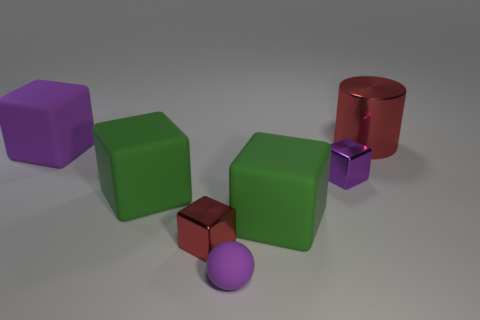Does the thing that is behind the purple rubber block have the same material as the purple block that is right of the purple matte cube?
Your answer should be compact. Yes. The large red shiny object has what shape?
Ensure brevity in your answer.  Cylinder. Is the number of large objects that are to the left of the matte ball greater than the number of green matte objects behind the big red shiny cylinder?
Make the answer very short. Yes. Does the red shiny thing that is in front of the red shiny cylinder have the same shape as the big green matte object on the left side of the tiny matte ball?
Make the answer very short. Yes. How many other things are the same size as the purple rubber block?
Offer a very short reply. 3. The metal cylinder is what size?
Give a very brief answer. Large. Do the purple cube right of the sphere and the large purple block have the same material?
Provide a short and direct response. No. What is the color of the other metal object that is the same shape as the small purple metal thing?
Make the answer very short. Red. There is a big rubber object to the right of the small red metallic block; is it the same color as the tiny ball?
Offer a very short reply. No. There is a big purple rubber object; are there any purple cubes right of it?
Your answer should be very brief. Yes. 